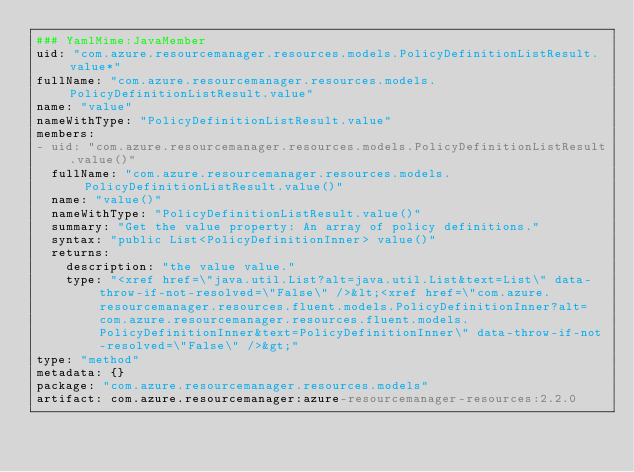Convert code to text. <code><loc_0><loc_0><loc_500><loc_500><_YAML_>### YamlMime:JavaMember
uid: "com.azure.resourcemanager.resources.models.PolicyDefinitionListResult.value*"
fullName: "com.azure.resourcemanager.resources.models.PolicyDefinitionListResult.value"
name: "value"
nameWithType: "PolicyDefinitionListResult.value"
members:
- uid: "com.azure.resourcemanager.resources.models.PolicyDefinitionListResult.value()"
  fullName: "com.azure.resourcemanager.resources.models.PolicyDefinitionListResult.value()"
  name: "value()"
  nameWithType: "PolicyDefinitionListResult.value()"
  summary: "Get the value property: An array of policy definitions."
  syntax: "public List<PolicyDefinitionInner> value()"
  returns:
    description: "the value value."
    type: "<xref href=\"java.util.List?alt=java.util.List&text=List\" data-throw-if-not-resolved=\"False\" />&lt;<xref href=\"com.azure.resourcemanager.resources.fluent.models.PolicyDefinitionInner?alt=com.azure.resourcemanager.resources.fluent.models.PolicyDefinitionInner&text=PolicyDefinitionInner\" data-throw-if-not-resolved=\"False\" />&gt;"
type: "method"
metadata: {}
package: "com.azure.resourcemanager.resources.models"
artifact: com.azure.resourcemanager:azure-resourcemanager-resources:2.2.0
</code> 